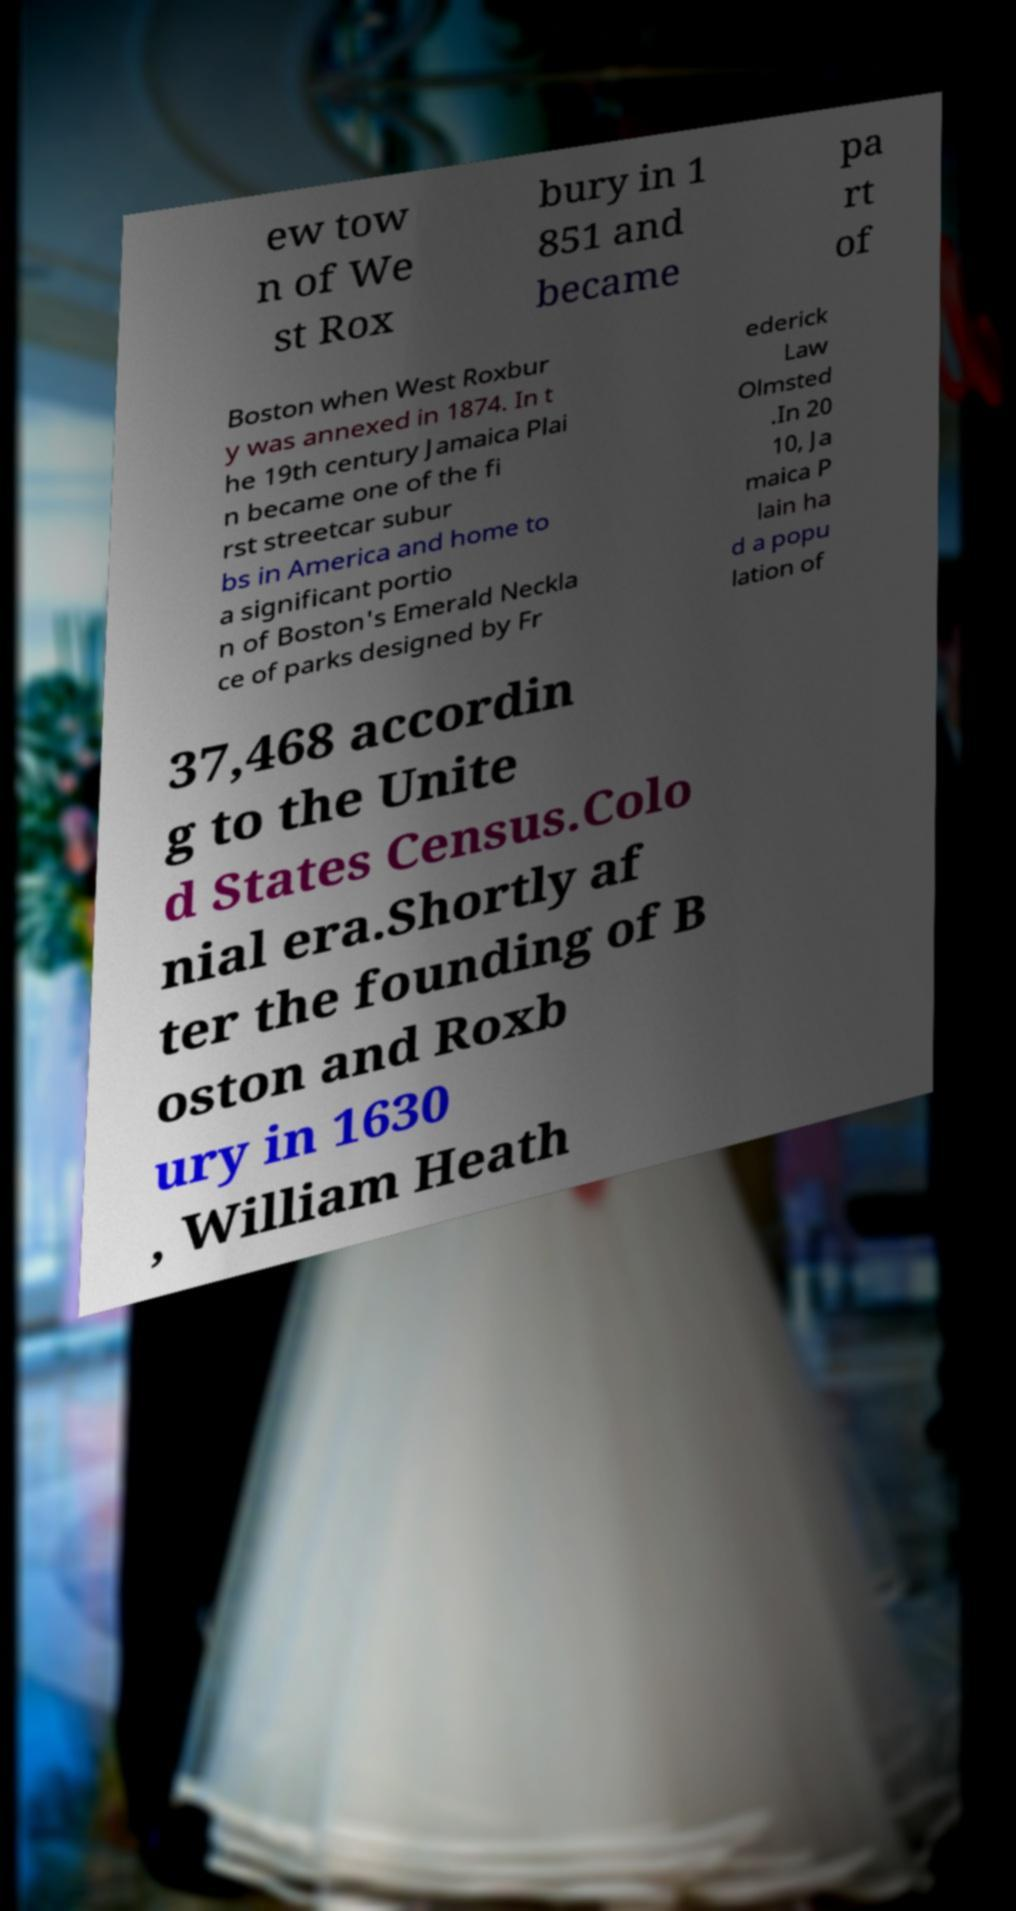Could you assist in decoding the text presented in this image and type it out clearly? ew tow n of We st Rox bury in 1 851 and became pa rt of Boston when West Roxbur y was annexed in 1874. In t he 19th century Jamaica Plai n became one of the fi rst streetcar subur bs in America and home to a significant portio n of Boston's Emerald Neckla ce of parks designed by Fr ederick Law Olmsted .In 20 10, Ja maica P lain ha d a popu lation of 37,468 accordin g to the Unite d States Census.Colo nial era.Shortly af ter the founding of B oston and Roxb ury in 1630 , William Heath 